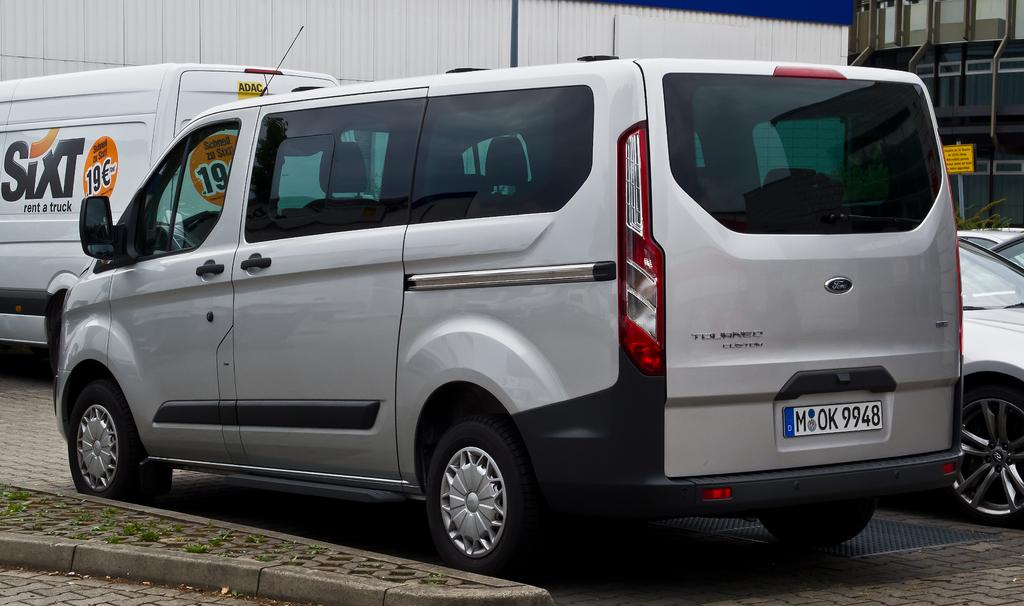<image>
Create a compact narrative representing the image presented. a silver van has a license plate of M OK 9948 